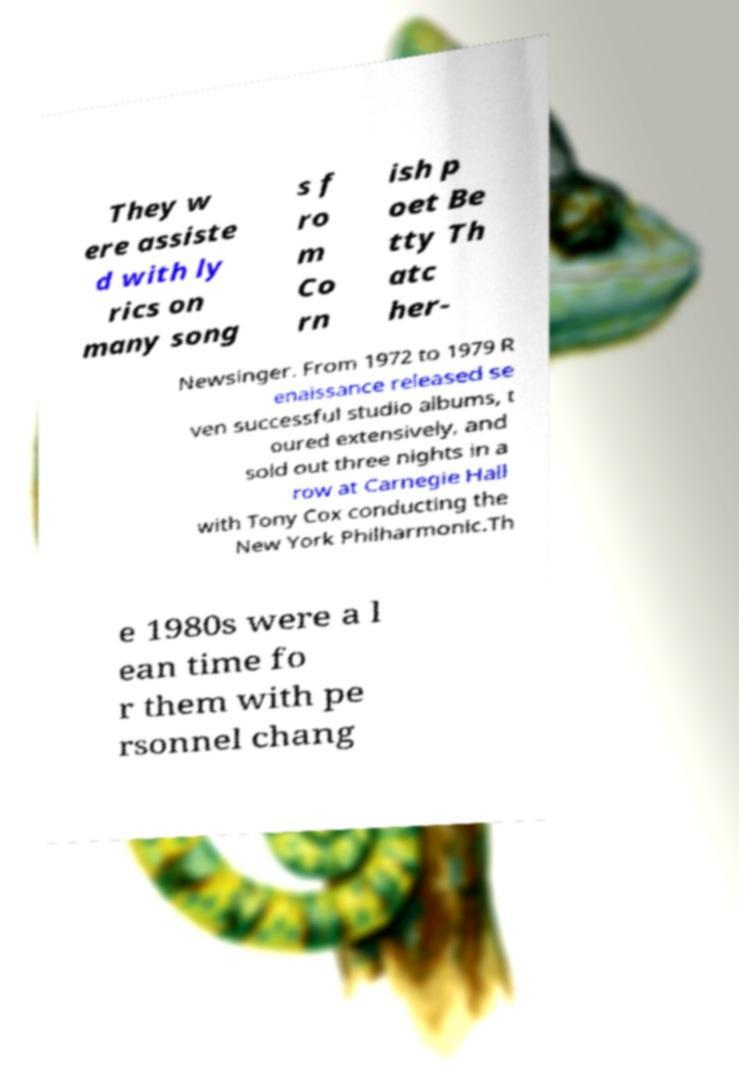For documentation purposes, I need the text within this image transcribed. Could you provide that? They w ere assiste d with ly rics on many song s f ro m Co rn ish p oet Be tty Th atc her- Newsinger. From 1972 to 1979 R enaissance released se ven successful studio albums, t oured extensively, and sold out three nights in a row at Carnegie Hall with Tony Cox conducting the New York Philharmonic.Th e 1980s were a l ean time fo r them with pe rsonnel chang 